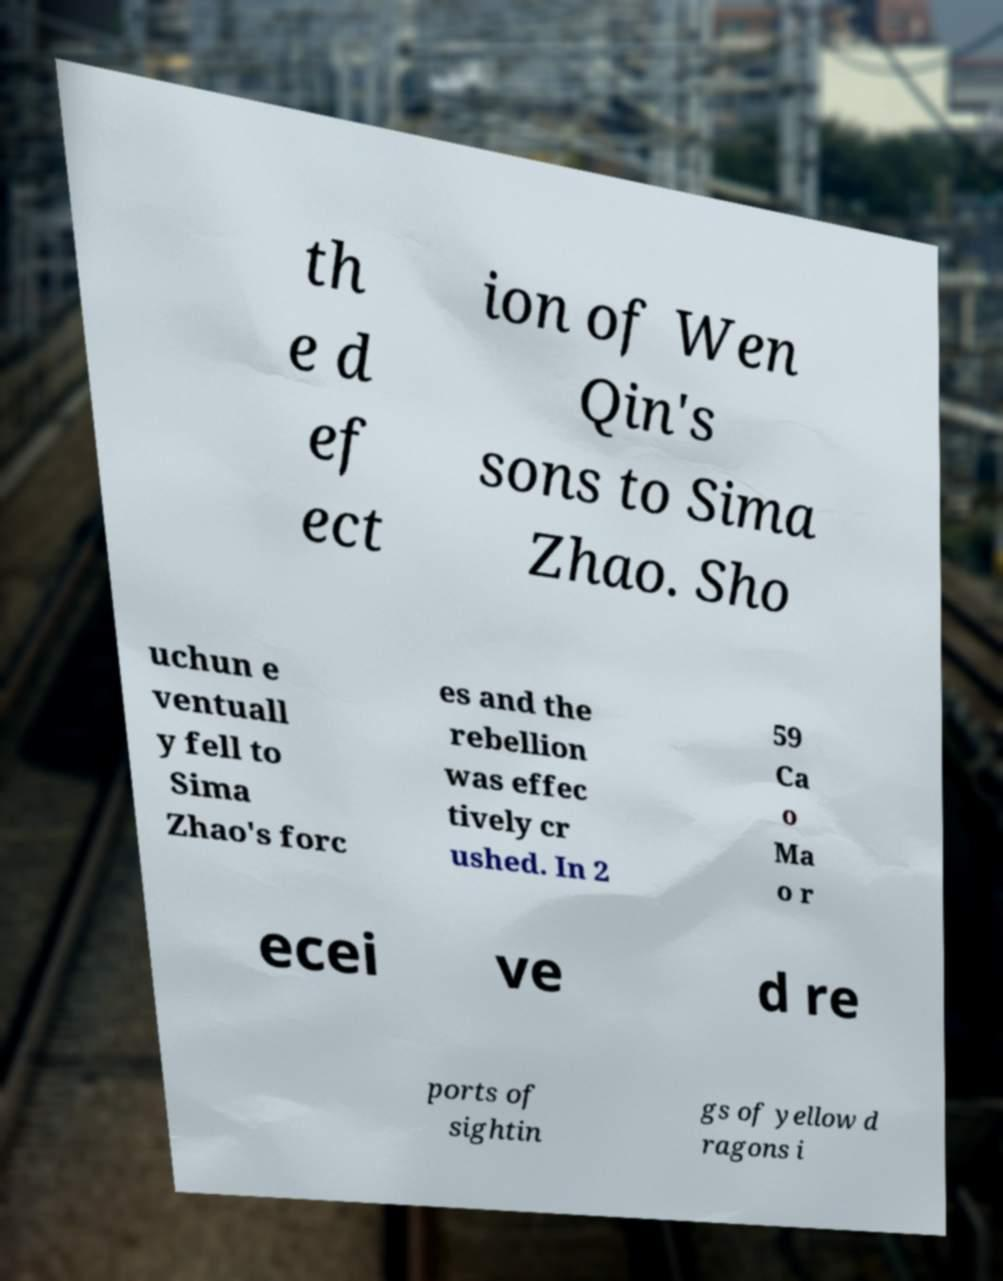What messages or text are displayed in this image? I need them in a readable, typed format. th e d ef ect ion of Wen Qin's sons to Sima Zhao. Sho uchun e ventuall y fell to Sima Zhao's forc es and the rebellion was effec tively cr ushed. In 2 59 Ca o Ma o r ecei ve d re ports of sightin gs of yellow d ragons i 